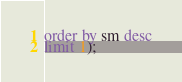Convert code to text. <code><loc_0><loc_0><loc_500><loc_500><_SQL_>order by sm desc
limit 1);
</code> 